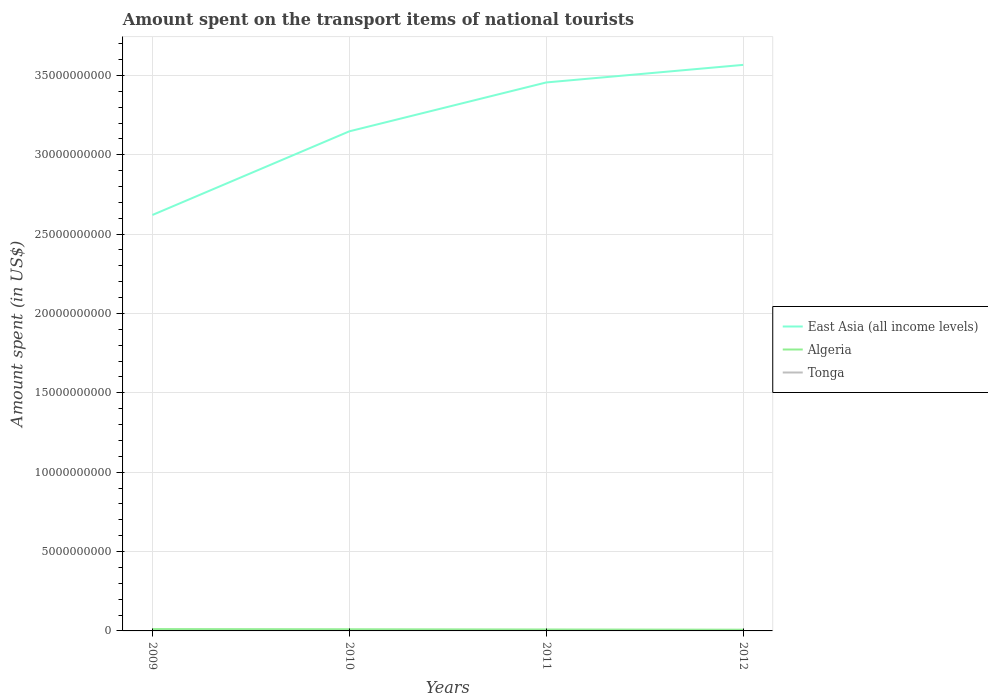How many different coloured lines are there?
Keep it short and to the point. 3. Across all years, what is the maximum amount spent on the transport items of national tourists in East Asia (all income levels)?
Ensure brevity in your answer.  2.62e+1. In which year was the amount spent on the transport items of national tourists in Tonga maximum?
Keep it short and to the point. 2009. What is the total amount spent on the transport items of national tourists in Algeria in the graph?
Your response must be concise. 1.10e+07. What is the difference between the highest and the second highest amount spent on the transport items of national tourists in Algeria?
Offer a terse response. 3.70e+07. What is the difference between the highest and the lowest amount spent on the transport items of national tourists in East Asia (all income levels)?
Your response must be concise. 2. Is the amount spent on the transport items of national tourists in Algeria strictly greater than the amount spent on the transport items of national tourists in Tonga over the years?
Your answer should be very brief. No. What is the difference between two consecutive major ticks on the Y-axis?
Offer a very short reply. 5.00e+09. Does the graph contain grids?
Give a very brief answer. Yes. Where does the legend appear in the graph?
Keep it short and to the point. Center right. What is the title of the graph?
Make the answer very short. Amount spent on the transport items of national tourists. Does "Liechtenstein" appear as one of the legend labels in the graph?
Keep it short and to the point. No. What is the label or title of the Y-axis?
Provide a succinct answer. Amount spent (in US$). What is the Amount spent (in US$) of East Asia (all income levels) in 2009?
Your response must be concise. 2.62e+1. What is the Amount spent (in US$) of Algeria in 2009?
Offer a very short reply. 1.15e+08. What is the Amount spent (in US$) of Tonga in 2009?
Ensure brevity in your answer.  8.00e+05. What is the Amount spent (in US$) in East Asia (all income levels) in 2010?
Your answer should be compact. 3.15e+1. What is the Amount spent (in US$) in Algeria in 2010?
Your response must be concise. 1.04e+08. What is the Amount spent (in US$) in Tonga in 2010?
Your answer should be compact. 1.10e+06. What is the Amount spent (in US$) of East Asia (all income levels) in 2011?
Keep it short and to the point. 3.46e+1. What is the Amount spent (in US$) of Algeria in 2011?
Your answer should be very brief. 9.10e+07. What is the Amount spent (in US$) in Tonga in 2011?
Your answer should be very brief. 1.70e+06. What is the Amount spent (in US$) of East Asia (all income levels) in 2012?
Provide a succinct answer. 3.57e+1. What is the Amount spent (in US$) of Algeria in 2012?
Keep it short and to the point. 7.80e+07. What is the Amount spent (in US$) in Tonga in 2012?
Your answer should be very brief. 1.80e+06. Across all years, what is the maximum Amount spent (in US$) of East Asia (all income levels)?
Offer a terse response. 3.57e+1. Across all years, what is the maximum Amount spent (in US$) in Algeria?
Offer a very short reply. 1.15e+08. Across all years, what is the maximum Amount spent (in US$) in Tonga?
Your response must be concise. 1.80e+06. Across all years, what is the minimum Amount spent (in US$) in East Asia (all income levels)?
Ensure brevity in your answer.  2.62e+1. Across all years, what is the minimum Amount spent (in US$) of Algeria?
Your answer should be very brief. 7.80e+07. What is the total Amount spent (in US$) of East Asia (all income levels) in the graph?
Your response must be concise. 1.28e+11. What is the total Amount spent (in US$) of Algeria in the graph?
Provide a succinct answer. 3.88e+08. What is the total Amount spent (in US$) in Tonga in the graph?
Your answer should be very brief. 5.40e+06. What is the difference between the Amount spent (in US$) of East Asia (all income levels) in 2009 and that in 2010?
Give a very brief answer. -5.27e+09. What is the difference between the Amount spent (in US$) of Algeria in 2009 and that in 2010?
Give a very brief answer. 1.10e+07. What is the difference between the Amount spent (in US$) in East Asia (all income levels) in 2009 and that in 2011?
Make the answer very short. -8.35e+09. What is the difference between the Amount spent (in US$) of Algeria in 2009 and that in 2011?
Your answer should be compact. 2.40e+07. What is the difference between the Amount spent (in US$) in Tonga in 2009 and that in 2011?
Ensure brevity in your answer.  -9.00e+05. What is the difference between the Amount spent (in US$) of East Asia (all income levels) in 2009 and that in 2012?
Your response must be concise. -9.46e+09. What is the difference between the Amount spent (in US$) in Algeria in 2009 and that in 2012?
Your answer should be very brief. 3.70e+07. What is the difference between the Amount spent (in US$) of Tonga in 2009 and that in 2012?
Offer a terse response. -1.00e+06. What is the difference between the Amount spent (in US$) in East Asia (all income levels) in 2010 and that in 2011?
Your response must be concise. -3.08e+09. What is the difference between the Amount spent (in US$) in Algeria in 2010 and that in 2011?
Provide a succinct answer. 1.30e+07. What is the difference between the Amount spent (in US$) of Tonga in 2010 and that in 2011?
Keep it short and to the point. -6.00e+05. What is the difference between the Amount spent (in US$) in East Asia (all income levels) in 2010 and that in 2012?
Your response must be concise. -4.19e+09. What is the difference between the Amount spent (in US$) in Algeria in 2010 and that in 2012?
Your answer should be compact. 2.60e+07. What is the difference between the Amount spent (in US$) in Tonga in 2010 and that in 2012?
Provide a succinct answer. -7.00e+05. What is the difference between the Amount spent (in US$) of East Asia (all income levels) in 2011 and that in 2012?
Your answer should be compact. -1.11e+09. What is the difference between the Amount spent (in US$) in Algeria in 2011 and that in 2012?
Your answer should be compact. 1.30e+07. What is the difference between the Amount spent (in US$) of East Asia (all income levels) in 2009 and the Amount spent (in US$) of Algeria in 2010?
Offer a terse response. 2.61e+1. What is the difference between the Amount spent (in US$) of East Asia (all income levels) in 2009 and the Amount spent (in US$) of Tonga in 2010?
Provide a succinct answer. 2.62e+1. What is the difference between the Amount spent (in US$) in Algeria in 2009 and the Amount spent (in US$) in Tonga in 2010?
Provide a short and direct response. 1.14e+08. What is the difference between the Amount spent (in US$) in East Asia (all income levels) in 2009 and the Amount spent (in US$) in Algeria in 2011?
Ensure brevity in your answer.  2.61e+1. What is the difference between the Amount spent (in US$) of East Asia (all income levels) in 2009 and the Amount spent (in US$) of Tonga in 2011?
Your response must be concise. 2.62e+1. What is the difference between the Amount spent (in US$) of Algeria in 2009 and the Amount spent (in US$) of Tonga in 2011?
Give a very brief answer. 1.13e+08. What is the difference between the Amount spent (in US$) of East Asia (all income levels) in 2009 and the Amount spent (in US$) of Algeria in 2012?
Your answer should be very brief. 2.61e+1. What is the difference between the Amount spent (in US$) in East Asia (all income levels) in 2009 and the Amount spent (in US$) in Tonga in 2012?
Your response must be concise. 2.62e+1. What is the difference between the Amount spent (in US$) of Algeria in 2009 and the Amount spent (in US$) of Tonga in 2012?
Offer a terse response. 1.13e+08. What is the difference between the Amount spent (in US$) of East Asia (all income levels) in 2010 and the Amount spent (in US$) of Algeria in 2011?
Offer a terse response. 3.14e+1. What is the difference between the Amount spent (in US$) in East Asia (all income levels) in 2010 and the Amount spent (in US$) in Tonga in 2011?
Provide a succinct answer. 3.15e+1. What is the difference between the Amount spent (in US$) of Algeria in 2010 and the Amount spent (in US$) of Tonga in 2011?
Offer a very short reply. 1.02e+08. What is the difference between the Amount spent (in US$) of East Asia (all income levels) in 2010 and the Amount spent (in US$) of Algeria in 2012?
Offer a terse response. 3.14e+1. What is the difference between the Amount spent (in US$) of East Asia (all income levels) in 2010 and the Amount spent (in US$) of Tonga in 2012?
Your answer should be very brief. 3.15e+1. What is the difference between the Amount spent (in US$) in Algeria in 2010 and the Amount spent (in US$) in Tonga in 2012?
Give a very brief answer. 1.02e+08. What is the difference between the Amount spent (in US$) of East Asia (all income levels) in 2011 and the Amount spent (in US$) of Algeria in 2012?
Your answer should be very brief. 3.45e+1. What is the difference between the Amount spent (in US$) of East Asia (all income levels) in 2011 and the Amount spent (in US$) of Tonga in 2012?
Your answer should be compact. 3.46e+1. What is the difference between the Amount spent (in US$) in Algeria in 2011 and the Amount spent (in US$) in Tonga in 2012?
Your answer should be compact. 8.92e+07. What is the average Amount spent (in US$) of East Asia (all income levels) per year?
Ensure brevity in your answer.  3.20e+1. What is the average Amount spent (in US$) of Algeria per year?
Provide a short and direct response. 9.70e+07. What is the average Amount spent (in US$) in Tonga per year?
Your answer should be very brief. 1.35e+06. In the year 2009, what is the difference between the Amount spent (in US$) in East Asia (all income levels) and Amount spent (in US$) in Algeria?
Provide a short and direct response. 2.61e+1. In the year 2009, what is the difference between the Amount spent (in US$) of East Asia (all income levels) and Amount spent (in US$) of Tonga?
Offer a terse response. 2.62e+1. In the year 2009, what is the difference between the Amount spent (in US$) in Algeria and Amount spent (in US$) in Tonga?
Ensure brevity in your answer.  1.14e+08. In the year 2010, what is the difference between the Amount spent (in US$) of East Asia (all income levels) and Amount spent (in US$) of Algeria?
Make the answer very short. 3.14e+1. In the year 2010, what is the difference between the Amount spent (in US$) in East Asia (all income levels) and Amount spent (in US$) in Tonga?
Give a very brief answer. 3.15e+1. In the year 2010, what is the difference between the Amount spent (in US$) in Algeria and Amount spent (in US$) in Tonga?
Ensure brevity in your answer.  1.03e+08. In the year 2011, what is the difference between the Amount spent (in US$) of East Asia (all income levels) and Amount spent (in US$) of Algeria?
Make the answer very short. 3.45e+1. In the year 2011, what is the difference between the Amount spent (in US$) of East Asia (all income levels) and Amount spent (in US$) of Tonga?
Offer a very short reply. 3.46e+1. In the year 2011, what is the difference between the Amount spent (in US$) in Algeria and Amount spent (in US$) in Tonga?
Ensure brevity in your answer.  8.93e+07. In the year 2012, what is the difference between the Amount spent (in US$) of East Asia (all income levels) and Amount spent (in US$) of Algeria?
Your answer should be compact. 3.56e+1. In the year 2012, what is the difference between the Amount spent (in US$) of East Asia (all income levels) and Amount spent (in US$) of Tonga?
Give a very brief answer. 3.57e+1. In the year 2012, what is the difference between the Amount spent (in US$) of Algeria and Amount spent (in US$) of Tonga?
Your answer should be compact. 7.62e+07. What is the ratio of the Amount spent (in US$) in East Asia (all income levels) in 2009 to that in 2010?
Ensure brevity in your answer.  0.83. What is the ratio of the Amount spent (in US$) in Algeria in 2009 to that in 2010?
Your answer should be very brief. 1.11. What is the ratio of the Amount spent (in US$) of Tonga in 2009 to that in 2010?
Make the answer very short. 0.73. What is the ratio of the Amount spent (in US$) of East Asia (all income levels) in 2009 to that in 2011?
Make the answer very short. 0.76. What is the ratio of the Amount spent (in US$) in Algeria in 2009 to that in 2011?
Offer a terse response. 1.26. What is the ratio of the Amount spent (in US$) of Tonga in 2009 to that in 2011?
Provide a short and direct response. 0.47. What is the ratio of the Amount spent (in US$) in East Asia (all income levels) in 2009 to that in 2012?
Ensure brevity in your answer.  0.73. What is the ratio of the Amount spent (in US$) of Algeria in 2009 to that in 2012?
Offer a terse response. 1.47. What is the ratio of the Amount spent (in US$) in Tonga in 2009 to that in 2012?
Your answer should be compact. 0.44. What is the ratio of the Amount spent (in US$) of East Asia (all income levels) in 2010 to that in 2011?
Your answer should be very brief. 0.91. What is the ratio of the Amount spent (in US$) in Algeria in 2010 to that in 2011?
Make the answer very short. 1.14. What is the ratio of the Amount spent (in US$) in Tonga in 2010 to that in 2011?
Your answer should be very brief. 0.65. What is the ratio of the Amount spent (in US$) in East Asia (all income levels) in 2010 to that in 2012?
Keep it short and to the point. 0.88. What is the ratio of the Amount spent (in US$) in Algeria in 2010 to that in 2012?
Your answer should be compact. 1.33. What is the ratio of the Amount spent (in US$) of Tonga in 2010 to that in 2012?
Make the answer very short. 0.61. What is the ratio of the Amount spent (in US$) of East Asia (all income levels) in 2011 to that in 2012?
Your answer should be compact. 0.97. What is the ratio of the Amount spent (in US$) in Algeria in 2011 to that in 2012?
Your answer should be compact. 1.17. What is the difference between the highest and the second highest Amount spent (in US$) in East Asia (all income levels)?
Offer a terse response. 1.11e+09. What is the difference between the highest and the second highest Amount spent (in US$) of Algeria?
Provide a short and direct response. 1.10e+07. What is the difference between the highest and the second highest Amount spent (in US$) of Tonga?
Your answer should be compact. 1.00e+05. What is the difference between the highest and the lowest Amount spent (in US$) in East Asia (all income levels)?
Offer a terse response. 9.46e+09. What is the difference between the highest and the lowest Amount spent (in US$) in Algeria?
Your response must be concise. 3.70e+07. 